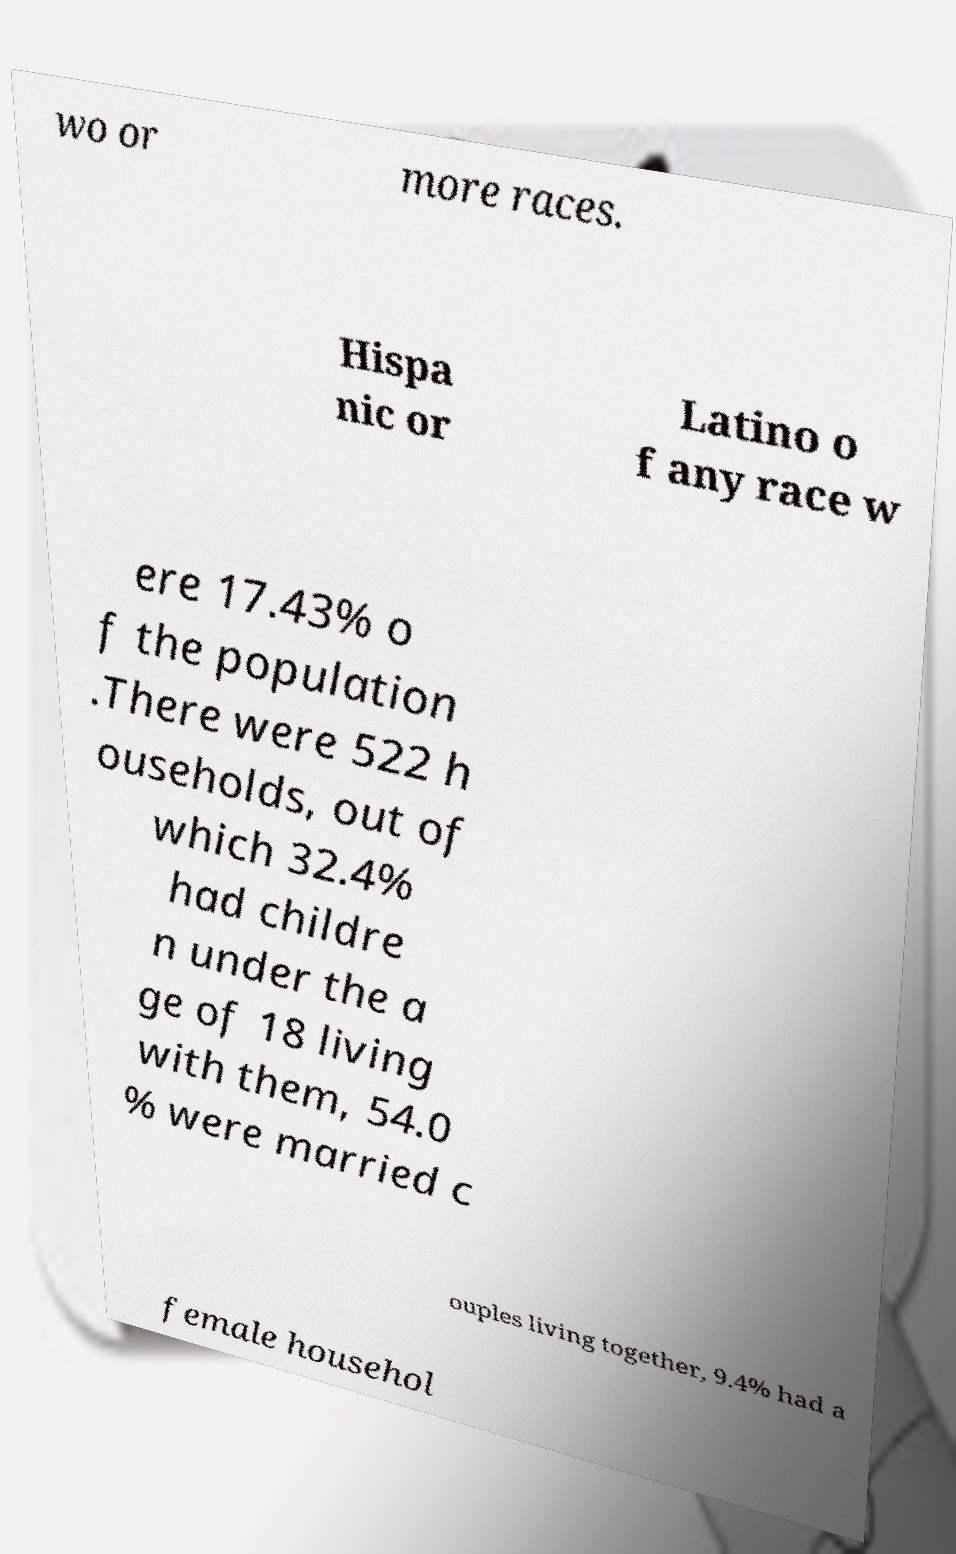For documentation purposes, I need the text within this image transcribed. Could you provide that? wo or more races. Hispa nic or Latino o f any race w ere 17.43% o f the population .There were 522 h ouseholds, out of which 32.4% had childre n under the a ge of 18 living with them, 54.0 % were married c ouples living together, 9.4% had a female househol 